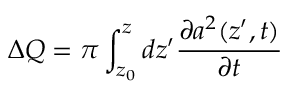<formula> <loc_0><loc_0><loc_500><loc_500>\Delta Q = \pi \int _ { z _ { 0 } } ^ { z } d z ^ { \prime } \frac { \partial a ^ { 2 } ( z ^ { \prime } , t ) } { \partial t }</formula> 